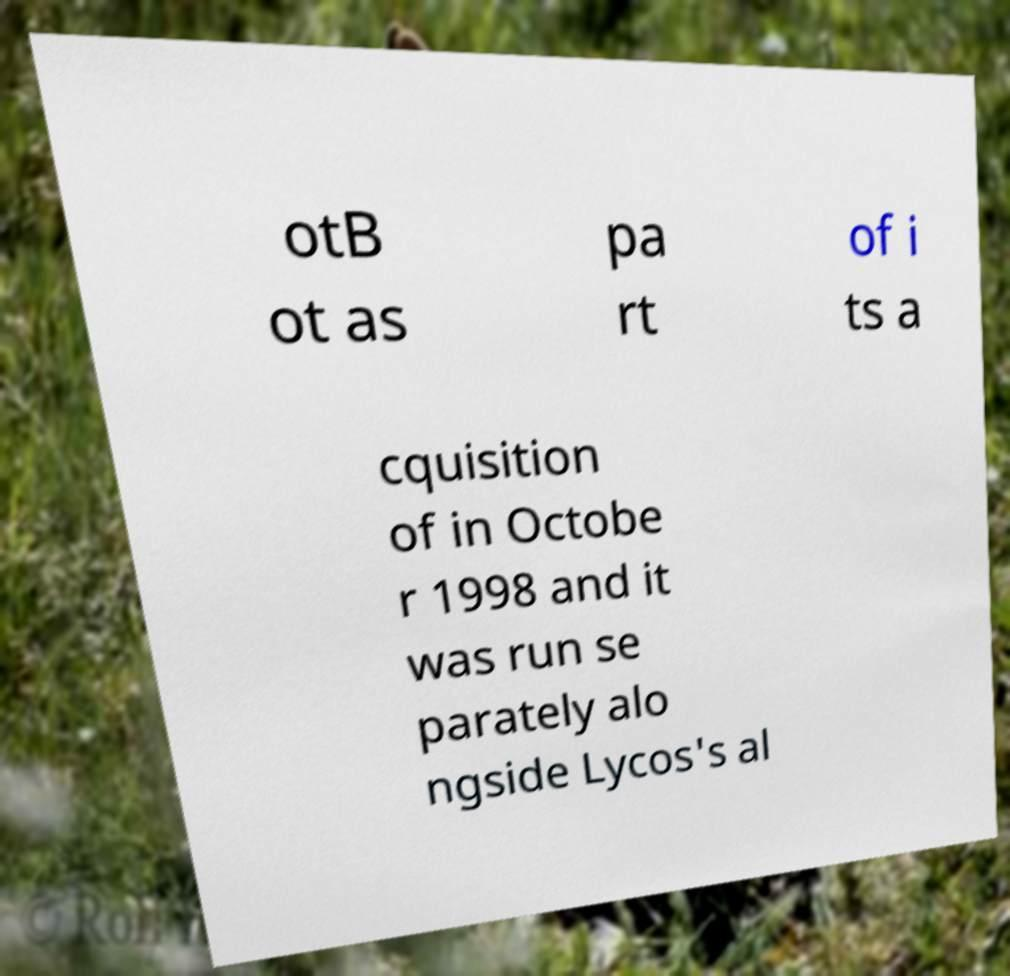For documentation purposes, I need the text within this image transcribed. Could you provide that? otB ot as pa rt of i ts a cquisition of in Octobe r 1998 and it was run se parately alo ngside Lycos's al 